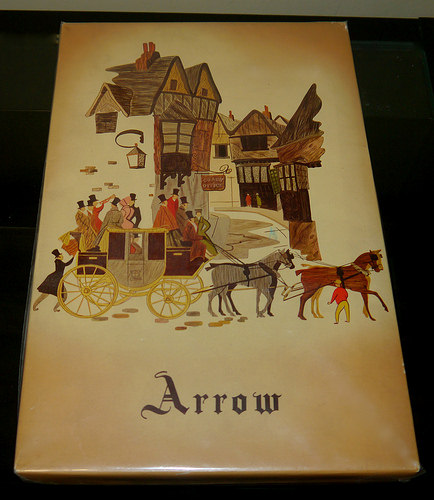<image>
Is the man next to the horse? Yes. The man is positioned adjacent to the horse, located nearby in the same general area. 